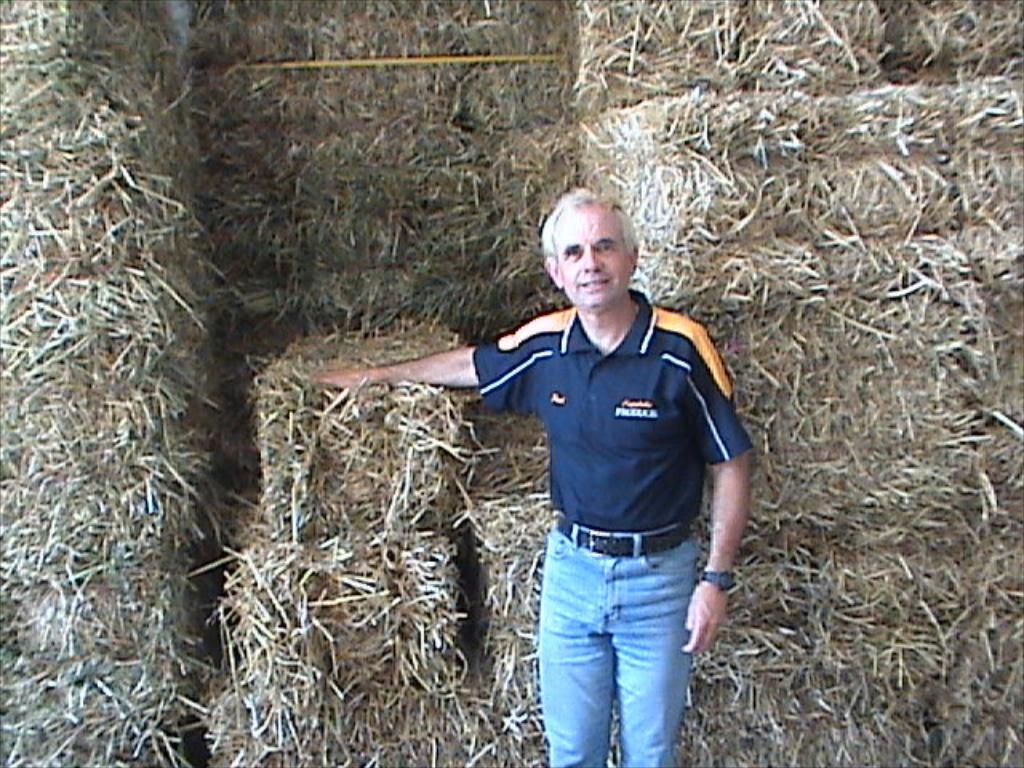Who is present in the image? There is a man in the image. What is the man wearing on his upper body? The man is wearing a blue T-shirt. What type of trousers is the man wearing? The man is wearing jeans trousers. What accessory is the man wearing around his waist? The man is wearing a belt. What can be seen in the background of the image? There is dried grass arranged in cubes in the background of the image. What type of can is visible in the image? There is no can present in the image. Is there a spot on the man's jeans trousers in the image? The provided facts do not mention any spots on the man's jeans trousers, so it cannot be determined from the image. 